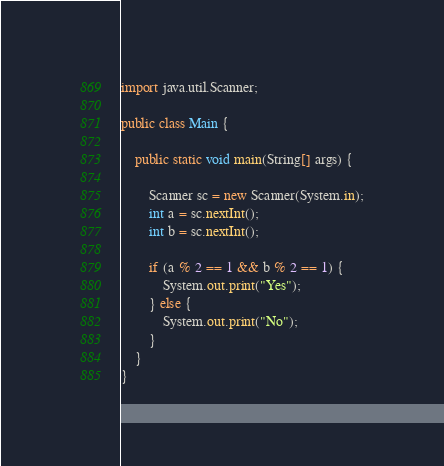Convert code to text. <code><loc_0><loc_0><loc_500><loc_500><_Java_>import java.util.Scanner;

public class Main {

	public static void main(String[] args) {

		Scanner sc = new Scanner(System.in);
		int a = sc.nextInt();
		int b = sc.nextInt();

		if (a % 2 == 1 && b % 2 == 1) {
			System.out.print("Yes");
		} else {
			System.out.print("No");
		}
	}
}</code> 